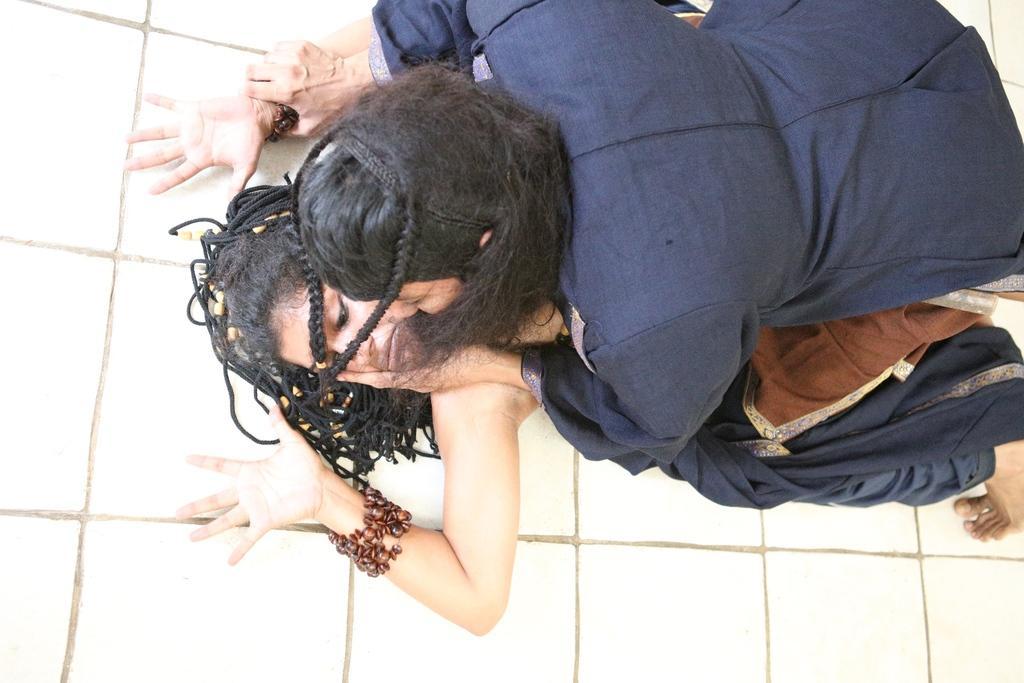In one or two sentences, can you explain what this image depicts? In this image we can see two persons. In the background of the image there is a white wall. 